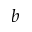<formula> <loc_0><loc_0><loc_500><loc_500>b</formula> 